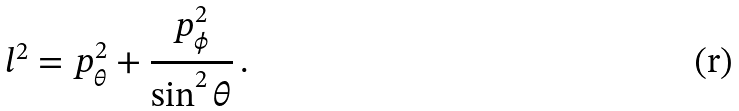<formula> <loc_0><loc_0><loc_500><loc_500>l ^ { 2 } = p ^ { 2 } _ { \theta } + \frac { p ^ { 2 } _ { \phi } } { \sin ^ { 2 } \theta } \, .</formula> 